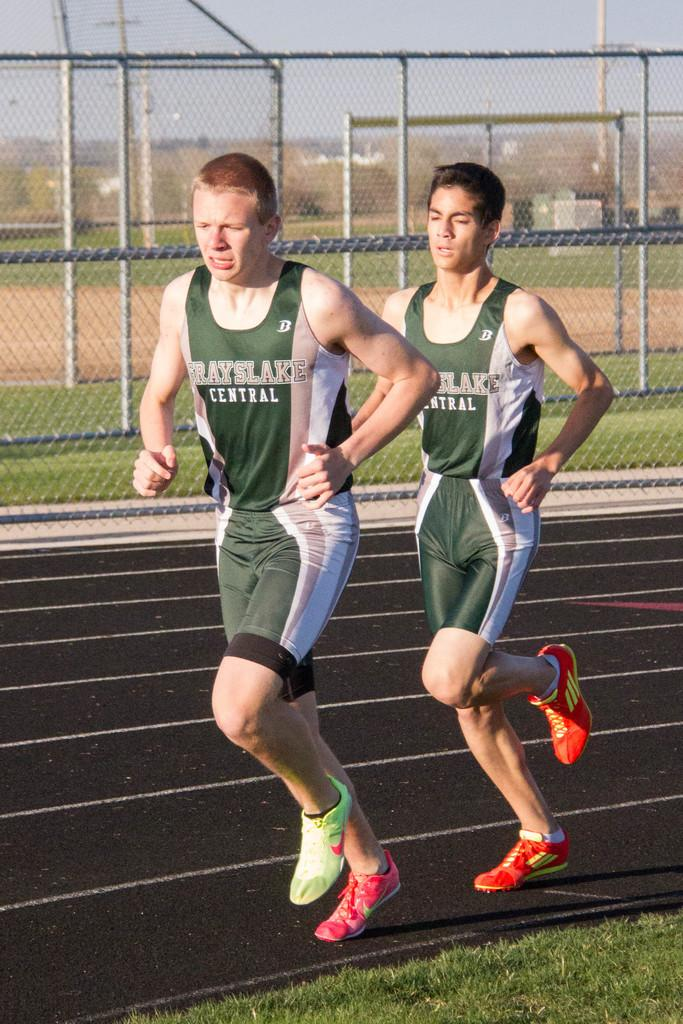<image>
Present a compact description of the photo's key features. a couple guys, one with the word central on his jersey 